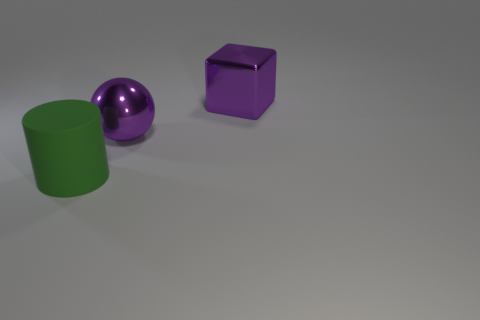There is a purple metal thing that is to the right of the purple metal object that is left of the purple shiny cube; how big is it?
Your answer should be compact. Large. What number of things are purple matte balls or big purple objects that are left of the big purple block?
Your response must be concise. 1. There is a purple metallic thing behind the large metallic sphere; is it the same shape as the rubber thing?
Offer a terse response. No. There is a shiny thing behind the purple shiny sphere that is left of the large purple cube; what number of big purple metal spheres are behind it?
Your answer should be compact. 0. Is there any other thing that is the same shape as the rubber thing?
Offer a very short reply. No. What number of things are either cubes or small blue metal balls?
Offer a very short reply. 1. There is a big matte object; is its shape the same as the purple shiny object that is in front of the block?
Your response must be concise. No. What shape is the big shiny object that is in front of the purple shiny cube?
Keep it short and to the point. Sphere. Is the size of the purple shiny object that is behind the purple shiny ball the same as the green matte object?
Keep it short and to the point. Yes. There is a object that is left of the big purple cube and on the right side of the matte object; what size is it?
Offer a terse response. Large. 